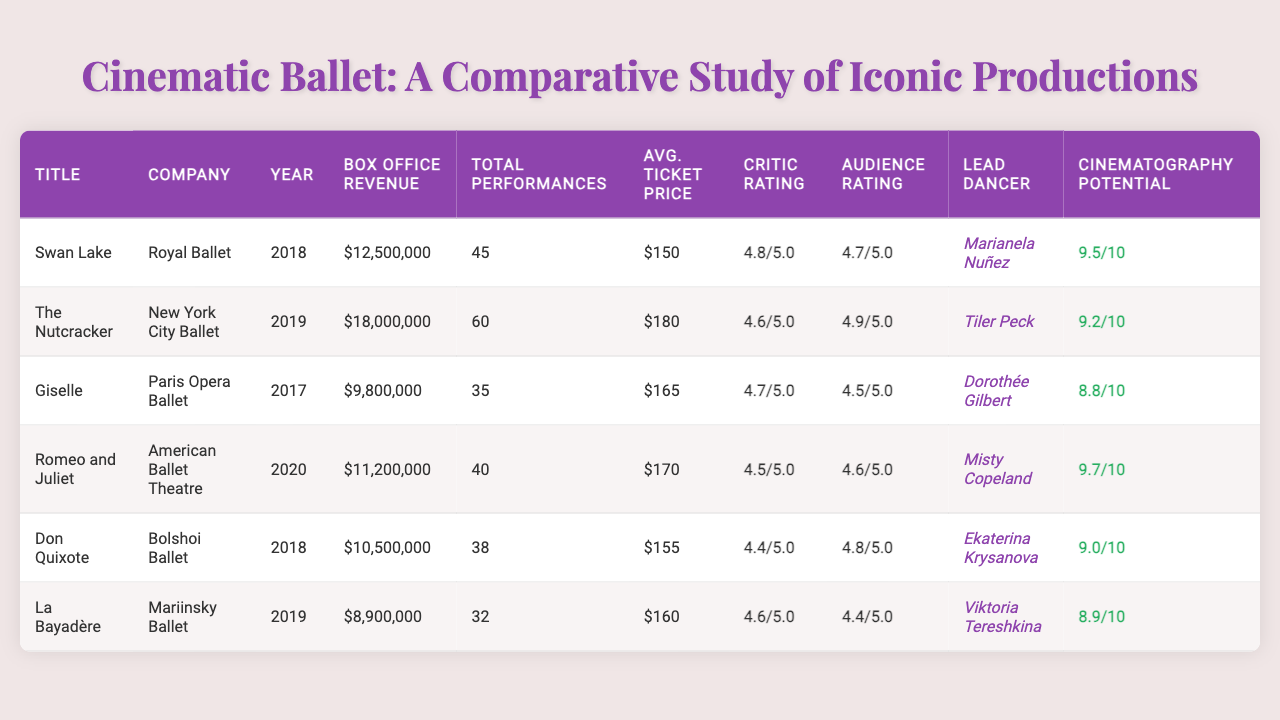What is the box office revenue of "Swan Lake"? The table lists the box office revenue for "Swan Lake" as $12,500,000 in the designated column.
Answer: $12,500,000 Which ballet production had the highest average ticket price? By comparing the average ticket prices listed in the table, "The Nutcracker" has the highest average ticket price of $180.
Answer: "The Nutcracker" What was the critic rating of "Romeo and Juliet"? The critic rating for "Romeo and Juliet" is found in the respective column, and it shows a rating of 4.5.
Answer: 4.5 How many total performances did "La Bayadère" have? The total performances for "La Bayadère" are displayed in the table as 32.
Answer: 32 What is the difference in box office revenue between "The Nutcracker" and "Giselle"? The box office revenue for "The Nutcracker" is $18,000,000 and for "Giselle" it's $9,800,000. The difference is $18,000,000 - $9,800,000 = $8,200,000.
Answer: $8,200,000 Which ballet production features Marianela Nuñez as the lead dancer? Looking at the lead dancer column, "Swan Lake" is the production featuring Marianela Nuñez.
Answer: "Swan Lake" What is the average box office revenue for all the productions listed? The total box office revenue for all productions is $12,500,000 + $18,000,000 + $9,800,000 + $11,200,000 + $10,500,000 + $8,900,000 = $71,900,000. There are 6 productions, so the average is $71,900,000 / 6 = $11,983,333.33.
Answer: $11,983,333.33 Did any production have a higher audience rating than its critic rating? By checking the ratings for each production, "La Bayadère" (audience rating 4.4, critic rating 4.6) and "Giselle" (audience rating 4.5, critic rating 4.7) both did not exceed their critic ratings. Conversely, "The Nutcracker" has an audience rating of 4.9 which is higher than the critic rating of 4.6.
Answer: Yes Which lead dancer has the highest cinematography potential according to the table? Analyzing the cinematography potential, Misty Copeland in "Romeo and Juliet" has the highest score of 9.7, more than any other lead dancer's potential.
Answer: Misty Copeland What is the total box office revenue of productions performed by the Bolshoi Ballet and Mariinsky Ballet? The box office revenue for Bolshoi Ballet's "Don Quixote" is $10,500,000 and for Mariinsky Ballet's "La Bayadère" is $8,900,000. The total revenue is $10,500,000 + $8,900,000 = $19,400,000.
Answer: $19,400,000 